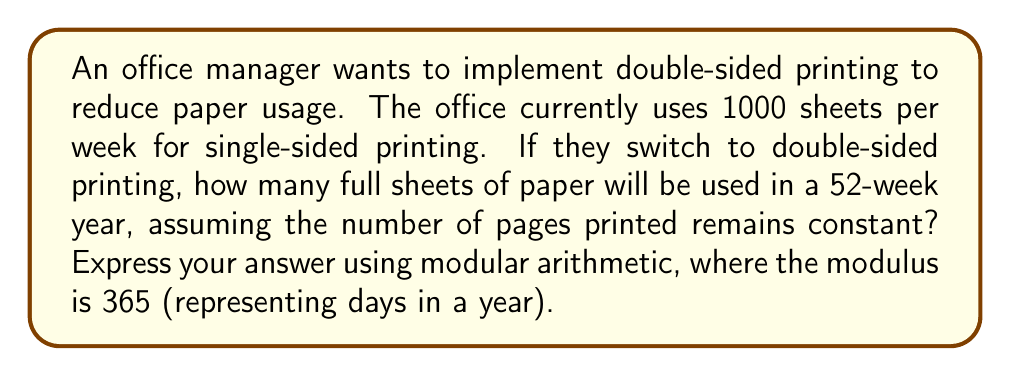Can you solve this math problem? Let's approach this step-by-step:

1) First, calculate the total number of pages printed in a year:
   $$1000 \text{ pages/week} \times 52 \text{ weeks} = 52,000 \text{ pages/year}$$

2) With double-sided printing, each sheet can hold 2 pages:
   $$\text{Sheets needed} = \left\lceil\frac{52,000 \text{ pages}}{2 \text{ pages/sheet}}\right\rceil = 26,000 \text{ sheets}$$

3) Now, we need to express this result using modular arithmetic with modulus 365:
   $$26,000 \equiv x \pmod{365}$$

4) To solve this, we can use the division algorithm:
   $$26,000 = 365q + r$$
   where $q$ is the quotient and $r$ is the remainder we're looking for.

5) Dividing 26,000 by 365:
   $$26,000 \div 365 = 71 \text{ remainder } 85$$

6) Therefore, in modular arithmetic:
   $$26,000 \equiv 85 \pmod{365}$$

This means that the number of sheets used in a year is equivalent to 85 when considering the modulus of 365 (days in a year).
Answer: $85 \pmod{365}$ 